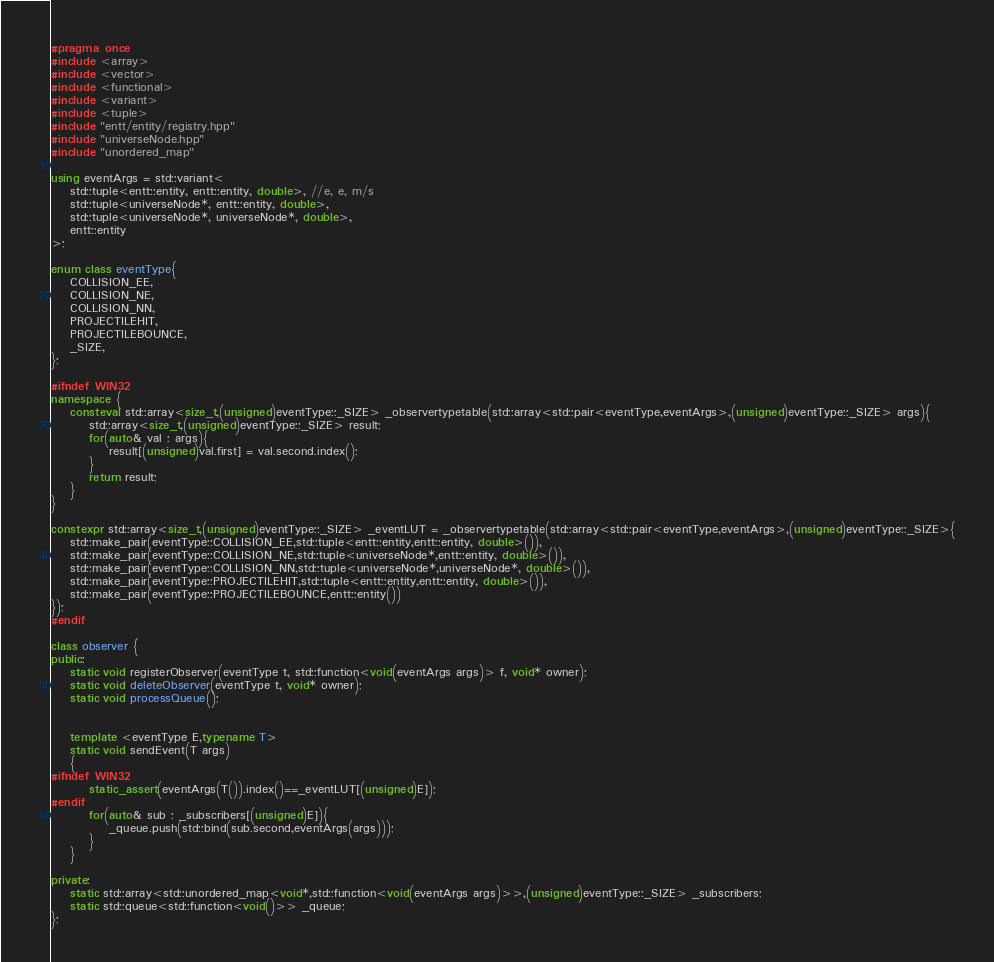Convert code to text. <code><loc_0><loc_0><loc_500><loc_500><_C++_>#pragma once
#include <array>
#include <vector>
#include <functional>
#include <variant>
#include <tuple>
#include "entt/entity/registry.hpp"
#include "universeNode.hpp"
#include "unordered_map"

using eventArgs = std::variant<
	std::tuple<entt::entity, entt::entity, double>, //e, e, m/s
	std::tuple<universeNode*, entt::entity, double>,
	std::tuple<universeNode*, universeNode*, double>,
	entt::entity
>;

enum class eventType{
	COLLISION_EE,
	COLLISION_NE,
	COLLISION_NN,
	PROJECTILEHIT,
	PROJECTILEBOUNCE,
	_SIZE,
};

#ifndef WIN32
namespace {
	consteval std::array<size_t,(unsigned)eventType::_SIZE> _observertypetable(std::array<std::pair<eventType,eventArgs>,(unsigned)eventType::_SIZE> args){
		std::array<size_t,(unsigned)eventType::_SIZE> result;
		for(auto& val : args){
			result[(unsigned)val.first] = val.second.index();
		}
		return result;
	}
}

constexpr std::array<size_t,(unsigned)eventType::_SIZE> _eventLUT = _observertypetable(std::array<std::pair<eventType,eventArgs>,(unsigned)eventType::_SIZE>{
	std::make_pair(eventType::COLLISION_EE,std::tuple<entt::entity,entt::entity, double>()),
	std::make_pair(eventType::COLLISION_NE,std::tuple<universeNode*,entt::entity, double>()),
	std::make_pair(eventType::COLLISION_NN,std::tuple<universeNode*,universeNode*, double>()),
	std::make_pair(eventType::PROJECTILEHIT,std::tuple<entt::entity,entt::entity, double>()),
	std::make_pair(eventType::PROJECTILEBOUNCE,entt::entity())
});
#endif

class observer {
public:
	static void registerObserver(eventType t, std::function<void(eventArgs args)> f, void* owner);
	static void deleteObserver(eventType t, void* owner);
	static void processQueue();


	template <eventType E,typename T>
	static void sendEvent(T args)
	{
#ifndef WIN32
		static_assert(eventArgs(T()).index()==_eventLUT[(unsigned)E]);
#endif
		for(auto& sub : _subscribers[(unsigned)E]){
			_queue.push(std::bind(sub.second,eventArgs(args)));
		}
	}

private:
	static std::array<std::unordered_map<void*,std::function<void(eventArgs args)>>,(unsigned)eventType::_SIZE> _subscribers;
	static std::queue<std::function<void()>> _queue;
};
</code> 